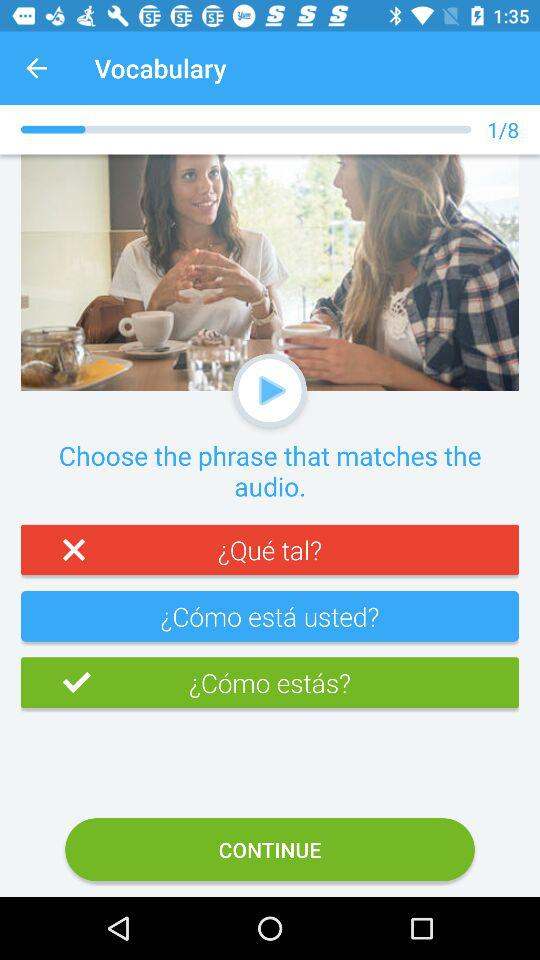What is the application name? The application name is "Vocabulary". 